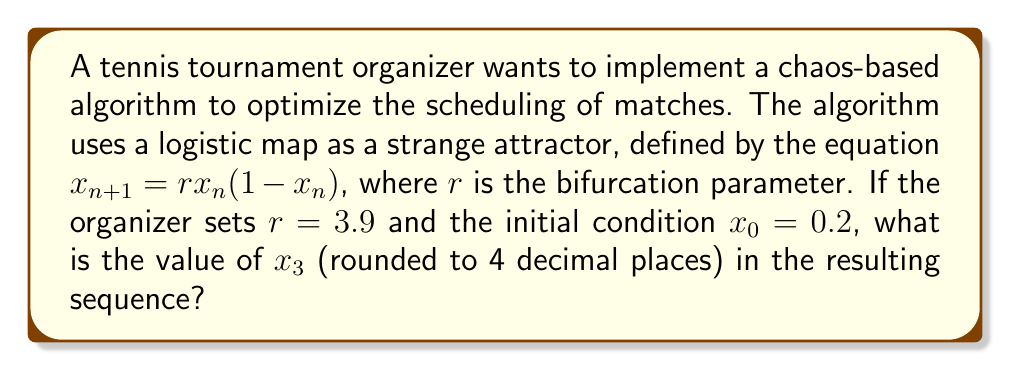Show me your answer to this math problem. To solve this problem, we need to iterate the logistic map equation three times:

Step 1: Calculate $x_1$
$$x_1 = rx_0(1-x_0) = 3.9 \cdot 0.2 \cdot (1-0.2) = 3.9 \cdot 0.2 \cdot 0.8 = 0.624$$

Step 2: Calculate $x_2$
$$x_2 = rx_1(1-x_1) = 3.9 \cdot 0.624 \cdot (1-0.624) = 3.9 \cdot 0.624 \cdot 0.376 = 0.9165984$$

Step 3: Calculate $x_3$
$$x_3 = rx_2(1-x_2) = 3.9 \cdot 0.9165984 \cdot (1-0.9165984) = 3.9 \cdot 0.9165984 \cdot 0.0834016 = 0.2976866$$

Step 4: Round the result to 4 decimal places
$$x_3 \approx 0.2977$$

This value represents the third iteration of the logistic map, which could be used to determine a specific aspect of the tournament schedule, such as court assignments or match order.
Answer: 0.2977 